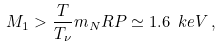<formula> <loc_0><loc_0><loc_500><loc_500>M _ { 1 } > \frac { T } { T _ { \nu } } m _ { N } R P \simeq 1 . 6 \ k e V \, ,</formula> 